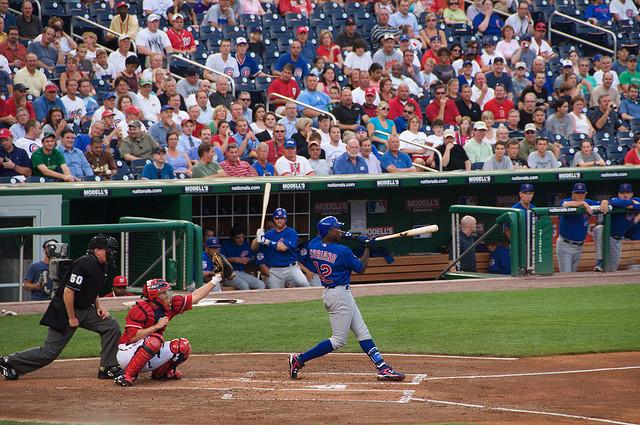Did he hit the ball?
Concise answer only. Yes. What team is at bat?
Give a very brief answer. Cubs. What sport is being played?
Give a very brief answer. Baseball. Who is behind the catcher?
Concise answer only. Umpire. 